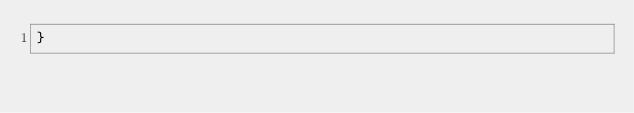<code> <loc_0><loc_0><loc_500><loc_500><_TypeScript_>}</code> 